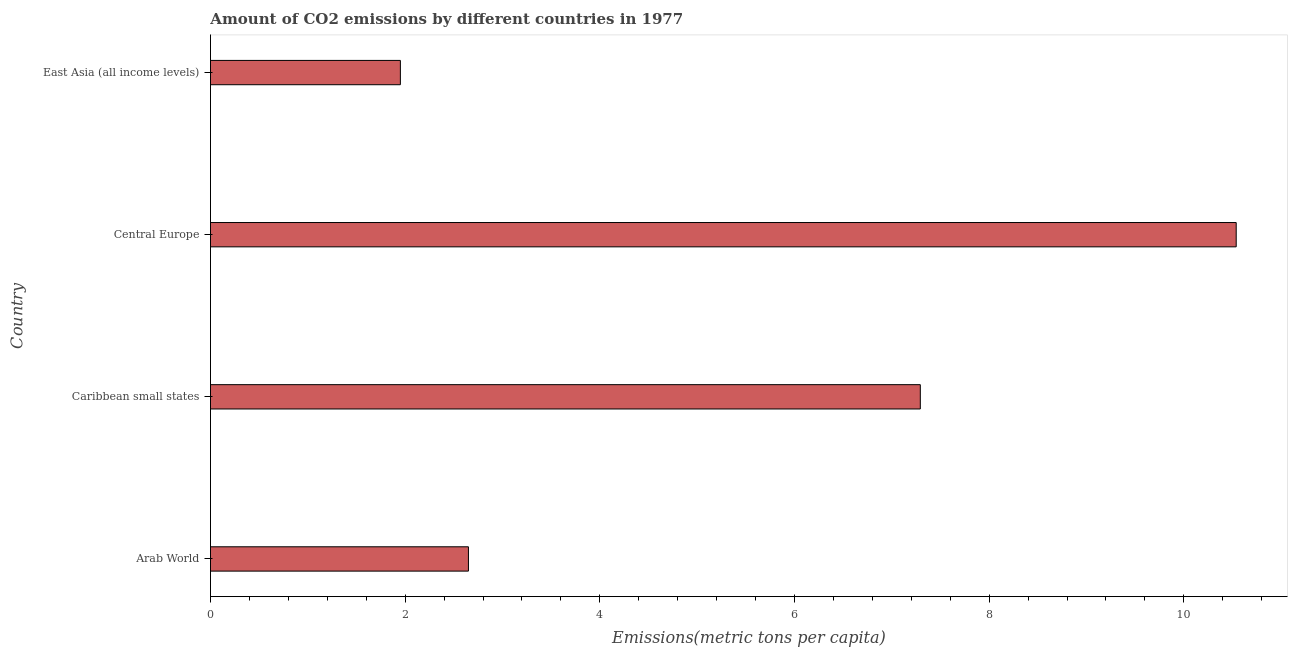What is the title of the graph?
Offer a very short reply. Amount of CO2 emissions by different countries in 1977. What is the label or title of the X-axis?
Give a very brief answer. Emissions(metric tons per capita). What is the label or title of the Y-axis?
Keep it short and to the point. Country. What is the amount of co2 emissions in Arab World?
Your answer should be compact. 2.65. Across all countries, what is the maximum amount of co2 emissions?
Ensure brevity in your answer.  10.54. Across all countries, what is the minimum amount of co2 emissions?
Offer a terse response. 1.95. In which country was the amount of co2 emissions maximum?
Your response must be concise. Central Europe. In which country was the amount of co2 emissions minimum?
Make the answer very short. East Asia (all income levels). What is the sum of the amount of co2 emissions?
Your answer should be very brief. 22.43. What is the difference between the amount of co2 emissions in Arab World and East Asia (all income levels)?
Make the answer very short. 0.7. What is the average amount of co2 emissions per country?
Your answer should be compact. 5.61. What is the median amount of co2 emissions?
Offer a very short reply. 4.97. In how many countries, is the amount of co2 emissions greater than 0.8 metric tons per capita?
Offer a terse response. 4. What is the ratio of the amount of co2 emissions in Arab World to that in Central Europe?
Your response must be concise. 0.25. Is the difference between the amount of co2 emissions in Arab World and Central Europe greater than the difference between any two countries?
Offer a very short reply. No. What is the difference between the highest and the second highest amount of co2 emissions?
Offer a very short reply. 3.25. Is the sum of the amount of co2 emissions in Caribbean small states and East Asia (all income levels) greater than the maximum amount of co2 emissions across all countries?
Make the answer very short. No. What is the difference between the highest and the lowest amount of co2 emissions?
Provide a short and direct response. 8.59. How many bars are there?
Provide a succinct answer. 4. Are all the bars in the graph horizontal?
Ensure brevity in your answer.  Yes. What is the difference between two consecutive major ticks on the X-axis?
Ensure brevity in your answer.  2. What is the Emissions(metric tons per capita) of Arab World?
Provide a short and direct response. 2.65. What is the Emissions(metric tons per capita) of Caribbean small states?
Your answer should be compact. 7.29. What is the Emissions(metric tons per capita) in Central Europe?
Your answer should be very brief. 10.54. What is the Emissions(metric tons per capita) of East Asia (all income levels)?
Provide a short and direct response. 1.95. What is the difference between the Emissions(metric tons per capita) in Arab World and Caribbean small states?
Provide a succinct answer. -4.64. What is the difference between the Emissions(metric tons per capita) in Arab World and Central Europe?
Make the answer very short. -7.89. What is the difference between the Emissions(metric tons per capita) in Arab World and East Asia (all income levels)?
Your answer should be very brief. 0.7. What is the difference between the Emissions(metric tons per capita) in Caribbean small states and Central Europe?
Give a very brief answer. -3.25. What is the difference between the Emissions(metric tons per capita) in Caribbean small states and East Asia (all income levels)?
Offer a very short reply. 5.34. What is the difference between the Emissions(metric tons per capita) in Central Europe and East Asia (all income levels)?
Your answer should be very brief. 8.59. What is the ratio of the Emissions(metric tons per capita) in Arab World to that in Caribbean small states?
Offer a very short reply. 0.36. What is the ratio of the Emissions(metric tons per capita) in Arab World to that in Central Europe?
Your answer should be compact. 0.25. What is the ratio of the Emissions(metric tons per capita) in Arab World to that in East Asia (all income levels)?
Keep it short and to the point. 1.36. What is the ratio of the Emissions(metric tons per capita) in Caribbean small states to that in Central Europe?
Offer a terse response. 0.69. What is the ratio of the Emissions(metric tons per capita) in Caribbean small states to that in East Asia (all income levels)?
Your answer should be compact. 3.74. What is the ratio of the Emissions(metric tons per capita) in Central Europe to that in East Asia (all income levels)?
Offer a terse response. 5.4. 